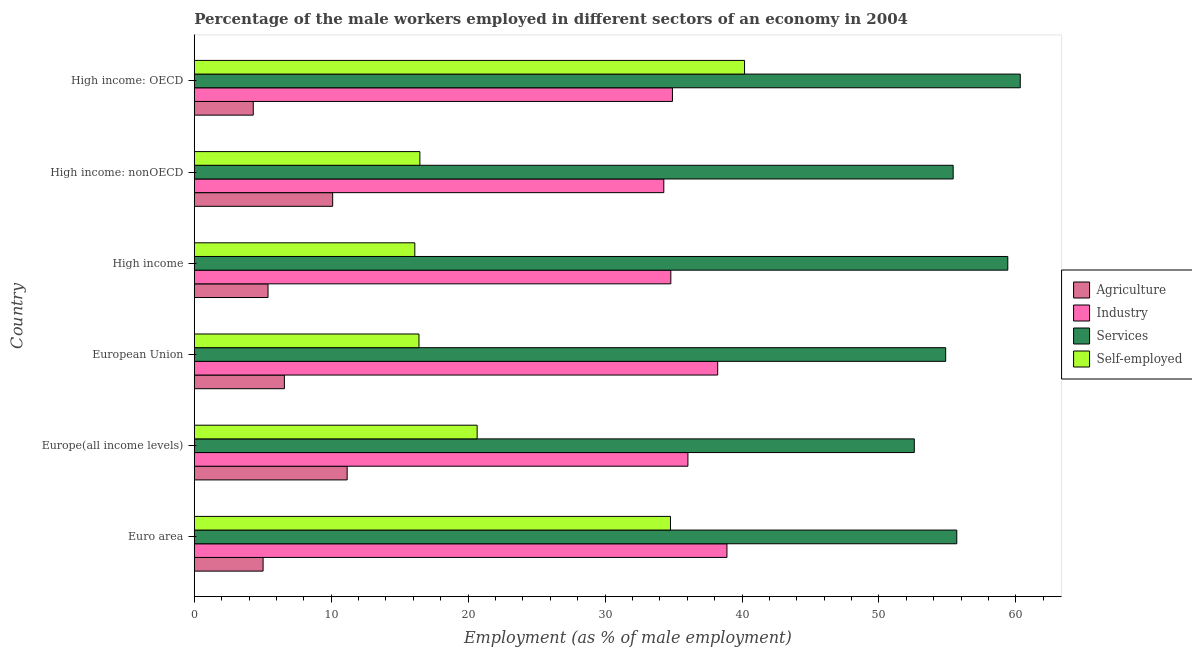Are the number of bars per tick equal to the number of legend labels?
Offer a terse response. Yes. Are the number of bars on each tick of the Y-axis equal?
Offer a very short reply. Yes. What is the label of the 6th group of bars from the top?
Your answer should be very brief. Euro area. In how many cases, is the number of bars for a given country not equal to the number of legend labels?
Provide a succinct answer. 0. What is the percentage of male workers in agriculture in European Union?
Provide a short and direct response. 6.58. Across all countries, what is the maximum percentage of male workers in agriculture?
Provide a short and direct response. 11.16. Across all countries, what is the minimum percentage of male workers in services?
Your answer should be compact. 52.58. In which country was the percentage of self employed male workers maximum?
Keep it short and to the point. High income: OECD. In which country was the percentage of male workers in agriculture minimum?
Make the answer very short. High income: OECD. What is the total percentage of male workers in industry in the graph?
Keep it short and to the point. 217.18. What is the difference between the percentage of male workers in industry in Europe(all income levels) and that in High income?
Provide a succinct answer. 1.25. What is the difference between the percentage of male workers in services in High income and the percentage of male workers in industry in High income: nonOECD?
Your answer should be very brief. 25.12. What is the average percentage of self employed male workers per country?
Give a very brief answer. 24.1. What is the difference between the percentage of male workers in agriculture and percentage of male workers in services in Europe(all income levels)?
Your response must be concise. -41.41. What is the ratio of the percentage of male workers in agriculture in Euro area to that in High income: nonOECD?
Keep it short and to the point. 0.5. Is the difference between the percentage of male workers in services in European Union and High income: OECD greater than the difference between the percentage of male workers in agriculture in European Union and High income: OECD?
Keep it short and to the point. No. What is the difference between the highest and the second highest percentage of male workers in agriculture?
Offer a very short reply. 1.06. What is the difference between the highest and the lowest percentage of male workers in services?
Keep it short and to the point. 7.74. Is the sum of the percentage of male workers in agriculture in Europe(all income levels) and High income: OECD greater than the maximum percentage of self employed male workers across all countries?
Give a very brief answer. No. What does the 1st bar from the top in High income: nonOECD represents?
Your answer should be very brief. Self-employed. What does the 3rd bar from the bottom in High income: OECD represents?
Your answer should be compact. Services. How many bars are there?
Make the answer very short. 24. Are the values on the major ticks of X-axis written in scientific E-notation?
Give a very brief answer. No. Does the graph contain any zero values?
Keep it short and to the point. No. Does the graph contain grids?
Your answer should be very brief. No. How are the legend labels stacked?
Keep it short and to the point. Vertical. What is the title of the graph?
Your answer should be compact. Percentage of the male workers employed in different sectors of an economy in 2004. Does "Finland" appear as one of the legend labels in the graph?
Offer a terse response. No. What is the label or title of the X-axis?
Offer a very short reply. Employment (as % of male employment). What is the Employment (as % of male employment) in Agriculture in Euro area?
Offer a terse response. 5.03. What is the Employment (as % of male employment) in Industry in Euro area?
Ensure brevity in your answer.  38.9. What is the Employment (as % of male employment) of Services in Euro area?
Provide a succinct answer. 55.68. What is the Employment (as % of male employment) in Self-employed in Euro area?
Offer a very short reply. 34.77. What is the Employment (as % of male employment) of Agriculture in Europe(all income levels)?
Your response must be concise. 11.16. What is the Employment (as % of male employment) in Industry in Europe(all income levels)?
Provide a succinct answer. 36.05. What is the Employment (as % of male employment) of Services in Europe(all income levels)?
Make the answer very short. 52.58. What is the Employment (as % of male employment) of Self-employed in Europe(all income levels)?
Ensure brevity in your answer.  20.66. What is the Employment (as % of male employment) of Agriculture in European Union?
Keep it short and to the point. 6.58. What is the Employment (as % of male employment) of Industry in European Union?
Give a very brief answer. 38.22. What is the Employment (as % of male employment) in Services in European Union?
Keep it short and to the point. 54.87. What is the Employment (as % of male employment) of Self-employed in European Union?
Provide a short and direct response. 16.41. What is the Employment (as % of male employment) of Agriculture in High income?
Offer a terse response. 5.39. What is the Employment (as % of male employment) in Industry in High income?
Keep it short and to the point. 34.8. What is the Employment (as % of male employment) in Services in High income?
Offer a terse response. 59.41. What is the Employment (as % of male employment) of Self-employed in High income?
Provide a succinct answer. 16.11. What is the Employment (as % of male employment) in Agriculture in High income: nonOECD?
Provide a succinct answer. 10.11. What is the Employment (as % of male employment) in Industry in High income: nonOECD?
Your answer should be compact. 34.29. What is the Employment (as % of male employment) of Services in High income: nonOECD?
Provide a succinct answer. 55.42. What is the Employment (as % of male employment) of Self-employed in High income: nonOECD?
Your response must be concise. 16.48. What is the Employment (as % of male employment) in Agriculture in High income: OECD?
Keep it short and to the point. 4.31. What is the Employment (as % of male employment) in Industry in High income: OECD?
Your response must be concise. 34.92. What is the Employment (as % of male employment) in Services in High income: OECD?
Keep it short and to the point. 60.32. What is the Employment (as % of male employment) in Self-employed in High income: OECD?
Your answer should be compact. 40.18. Across all countries, what is the maximum Employment (as % of male employment) in Agriculture?
Your response must be concise. 11.16. Across all countries, what is the maximum Employment (as % of male employment) in Industry?
Give a very brief answer. 38.9. Across all countries, what is the maximum Employment (as % of male employment) in Services?
Provide a short and direct response. 60.32. Across all countries, what is the maximum Employment (as % of male employment) in Self-employed?
Keep it short and to the point. 40.18. Across all countries, what is the minimum Employment (as % of male employment) of Agriculture?
Offer a terse response. 4.31. Across all countries, what is the minimum Employment (as % of male employment) of Industry?
Provide a succinct answer. 34.29. Across all countries, what is the minimum Employment (as % of male employment) of Services?
Give a very brief answer. 52.58. Across all countries, what is the minimum Employment (as % of male employment) of Self-employed?
Offer a very short reply. 16.11. What is the total Employment (as % of male employment) in Agriculture in the graph?
Ensure brevity in your answer.  42.57. What is the total Employment (as % of male employment) in Industry in the graph?
Offer a very short reply. 217.18. What is the total Employment (as % of male employment) in Services in the graph?
Give a very brief answer. 338.27. What is the total Employment (as % of male employment) of Self-employed in the graph?
Make the answer very short. 144.6. What is the difference between the Employment (as % of male employment) in Agriculture in Euro area and that in Europe(all income levels)?
Offer a very short reply. -6.14. What is the difference between the Employment (as % of male employment) in Industry in Euro area and that in Europe(all income levels)?
Your response must be concise. 2.85. What is the difference between the Employment (as % of male employment) in Services in Euro area and that in Europe(all income levels)?
Give a very brief answer. 3.1. What is the difference between the Employment (as % of male employment) of Self-employed in Euro area and that in Europe(all income levels)?
Give a very brief answer. 14.12. What is the difference between the Employment (as % of male employment) of Agriculture in Euro area and that in European Union?
Your answer should be very brief. -1.55. What is the difference between the Employment (as % of male employment) in Industry in Euro area and that in European Union?
Your answer should be compact. 0.68. What is the difference between the Employment (as % of male employment) of Services in Euro area and that in European Union?
Provide a succinct answer. 0.81. What is the difference between the Employment (as % of male employment) in Self-employed in Euro area and that in European Union?
Offer a very short reply. 18.37. What is the difference between the Employment (as % of male employment) of Agriculture in Euro area and that in High income?
Your answer should be very brief. -0.36. What is the difference between the Employment (as % of male employment) in Industry in Euro area and that in High income?
Make the answer very short. 4.1. What is the difference between the Employment (as % of male employment) in Services in Euro area and that in High income?
Your response must be concise. -3.73. What is the difference between the Employment (as % of male employment) of Self-employed in Euro area and that in High income?
Your answer should be very brief. 18.67. What is the difference between the Employment (as % of male employment) in Agriculture in Euro area and that in High income: nonOECD?
Provide a succinct answer. -5.08. What is the difference between the Employment (as % of male employment) of Industry in Euro area and that in High income: nonOECD?
Keep it short and to the point. 4.61. What is the difference between the Employment (as % of male employment) of Services in Euro area and that in High income: nonOECD?
Offer a terse response. 0.26. What is the difference between the Employment (as % of male employment) in Self-employed in Euro area and that in High income: nonOECD?
Offer a terse response. 18.3. What is the difference between the Employment (as % of male employment) in Agriculture in Euro area and that in High income: OECD?
Your response must be concise. 0.72. What is the difference between the Employment (as % of male employment) in Industry in Euro area and that in High income: OECD?
Make the answer very short. 3.98. What is the difference between the Employment (as % of male employment) of Services in Euro area and that in High income: OECD?
Keep it short and to the point. -4.64. What is the difference between the Employment (as % of male employment) of Self-employed in Euro area and that in High income: OECD?
Make the answer very short. -5.41. What is the difference between the Employment (as % of male employment) in Agriculture in Europe(all income levels) and that in European Union?
Make the answer very short. 4.58. What is the difference between the Employment (as % of male employment) in Industry in Europe(all income levels) and that in European Union?
Keep it short and to the point. -2.17. What is the difference between the Employment (as % of male employment) in Services in Europe(all income levels) and that in European Union?
Provide a short and direct response. -2.29. What is the difference between the Employment (as % of male employment) in Self-employed in Europe(all income levels) and that in European Union?
Make the answer very short. 4.25. What is the difference between the Employment (as % of male employment) in Agriculture in Europe(all income levels) and that in High income?
Keep it short and to the point. 5.78. What is the difference between the Employment (as % of male employment) in Industry in Europe(all income levels) and that in High income?
Provide a short and direct response. 1.25. What is the difference between the Employment (as % of male employment) of Services in Europe(all income levels) and that in High income?
Offer a very short reply. -6.83. What is the difference between the Employment (as % of male employment) of Self-employed in Europe(all income levels) and that in High income?
Your answer should be very brief. 4.55. What is the difference between the Employment (as % of male employment) in Agriculture in Europe(all income levels) and that in High income: nonOECD?
Provide a short and direct response. 1.06. What is the difference between the Employment (as % of male employment) of Industry in Europe(all income levels) and that in High income: nonOECD?
Make the answer very short. 1.76. What is the difference between the Employment (as % of male employment) of Services in Europe(all income levels) and that in High income: nonOECD?
Keep it short and to the point. -2.84. What is the difference between the Employment (as % of male employment) of Self-employed in Europe(all income levels) and that in High income: nonOECD?
Make the answer very short. 4.18. What is the difference between the Employment (as % of male employment) of Agriculture in Europe(all income levels) and that in High income: OECD?
Keep it short and to the point. 6.86. What is the difference between the Employment (as % of male employment) in Industry in Europe(all income levels) and that in High income: OECD?
Provide a short and direct response. 1.13. What is the difference between the Employment (as % of male employment) of Services in Europe(all income levels) and that in High income: OECD?
Provide a succinct answer. -7.74. What is the difference between the Employment (as % of male employment) of Self-employed in Europe(all income levels) and that in High income: OECD?
Offer a terse response. -19.53. What is the difference between the Employment (as % of male employment) in Agriculture in European Union and that in High income?
Make the answer very short. 1.19. What is the difference between the Employment (as % of male employment) in Industry in European Union and that in High income?
Keep it short and to the point. 3.42. What is the difference between the Employment (as % of male employment) of Services in European Union and that in High income?
Offer a terse response. -4.54. What is the difference between the Employment (as % of male employment) of Self-employed in European Union and that in High income?
Offer a terse response. 0.3. What is the difference between the Employment (as % of male employment) of Agriculture in European Union and that in High income: nonOECD?
Provide a short and direct response. -3.53. What is the difference between the Employment (as % of male employment) of Industry in European Union and that in High income: nonOECD?
Your answer should be compact. 3.94. What is the difference between the Employment (as % of male employment) of Services in European Union and that in High income: nonOECD?
Your response must be concise. -0.55. What is the difference between the Employment (as % of male employment) in Self-employed in European Union and that in High income: nonOECD?
Your answer should be compact. -0.07. What is the difference between the Employment (as % of male employment) in Agriculture in European Union and that in High income: OECD?
Give a very brief answer. 2.27. What is the difference between the Employment (as % of male employment) in Industry in European Union and that in High income: OECD?
Your answer should be compact. 3.31. What is the difference between the Employment (as % of male employment) of Services in European Union and that in High income: OECD?
Your response must be concise. -5.45. What is the difference between the Employment (as % of male employment) of Self-employed in European Union and that in High income: OECD?
Your answer should be compact. -23.78. What is the difference between the Employment (as % of male employment) in Agriculture in High income and that in High income: nonOECD?
Offer a very short reply. -4.72. What is the difference between the Employment (as % of male employment) in Industry in High income and that in High income: nonOECD?
Provide a short and direct response. 0.51. What is the difference between the Employment (as % of male employment) in Services in High income and that in High income: nonOECD?
Keep it short and to the point. 3.99. What is the difference between the Employment (as % of male employment) in Self-employed in High income and that in High income: nonOECD?
Offer a terse response. -0.37. What is the difference between the Employment (as % of male employment) of Agriculture in High income and that in High income: OECD?
Offer a very short reply. 1.08. What is the difference between the Employment (as % of male employment) of Industry in High income and that in High income: OECD?
Your answer should be very brief. -0.12. What is the difference between the Employment (as % of male employment) of Services in High income and that in High income: OECD?
Keep it short and to the point. -0.91. What is the difference between the Employment (as % of male employment) of Self-employed in High income and that in High income: OECD?
Keep it short and to the point. -24.08. What is the difference between the Employment (as % of male employment) in Agriculture in High income: nonOECD and that in High income: OECD?
Offer a terse response. 5.8. What is the difference between the Employment (as % of male employment) in Industry in High income: nonOECD and that in High income: OECD?
Your response must be concise. -0.63. What is the difference between the Employment (as % of male employment) of Services in High income: nonOECD and that in High income: OECD?
Offer a terse response. -4.9. What is the difference between the Employment (as % of male employment) of Self-employed in High income: nonOECD and that in High income: OECD?
Your response must be concise. -23.71. What is the difference between the Employment (as % of male employment) in Agriculture in Euro area and the Employment (as % of male employment) in Industry in Europe(all income levels)?
Your response must be concise. -31.02. What is the difference between the Employment (as % of male employment) in Agriculture in Euro area and the Employment (as % of male employment) in Services in Europe(all income levels)?
Your response must be concise. -47.55. What is the difference between the Employment (as % of male employment) in Agriculture in Euro area and the Employment (as % of male employment) in Self-employed in Europe(all income levels)?
Make the answer very short. -15.63. What is the difference between the Employment (as % of male employment) of Industry in Euro area and the Employment (as % of male employment) of Services in Europe(all income levels)?
Your answer should be very brief. -13.68. What is the difference between the Employment (as % of male employment) of Industry in Euro area and the Employment (as % of male employment) of Self-employed in Europe(all income levels)?
Your answer should be compact. 18.24. What is the difference between the Employment (as % of male employment) in Services in Euro area and the Employment (as % of male employment) in Self-employed in Europe(all income levels)?
Ensure brevity in your answer.  35.03. What is the difference between the Employment (as % of male employment) of Agriculture in Euro area and the Employment (as % of male employment) of Industry in European Union?
Keep it short and to the point. -33.2. What is the difference between the Employment (as % of male employment) in Agriculture in Euro area and the Employment (as % of male employment) in Services in European Union?
Make the answer very short. -49.84. What is the difference between the Employment (as % of male employment) in Agriculture in Euro area and the Employment (as % of male employment) in Self-employed in European Union?
Provide a short and direct response. -11.38. What is the difference between the Employment (as % of male employment) in Industry in Euro area and the Employment (as % of male employment) in Services in European Union?
Your response must be concise. -15.97. What is the difference between the Employment (as % of male employment) in Industry in Euro area and the Employment (as % of male employment) in Self-employed in European Union?
Make the answer very short. 22.49. What is the difference between the Employment (as % of male employment) of Services in Euro area and the Employment (as % of male employment) of Self-employed in European Union?
Provide a short and direct response. 39.27. What is the difference between the Employment (as % of male employment) of Agriculture in Euro area and the Employment (as % of male employment) of Industry in High income?
Offer a terse response. -29.77. What is the difference between the Employment (as % of male employment) in Agriculture in Euro area and the Employment (as % of male employment) in Services in High income?
Make the answer very short. -54.38. What is the difference between the Employment (as % of male employment) of Agriculture in Euro area and the Employment (as % of male employment) of Self-employed in High income?
Offer a very short reply. -11.08. What is the difference between the Employment (as % of male employment) of Industry in Euro area and the Employment (as % of male employment) of Services in High income?
Provide a short and direct response. -20.51. What is the difference between the Employment (as % of male employment) in Industry in Euro area and the Employment (as % of male employment) in Self-employed in High income?
Make the answer very short. 22.79. What is the difference between the Employment (as % of male employment) of Services in Euro area and the Employment (as % of male employment) of Self-employed in High income?
Your answer should be compact. 39.58. What is the difference between the Employment (as % of male employment) of Agriculture in Euro area and the Employment (as % of male employment) of Industry in High income: nonOECD?
Your answer should be very brief. -29.26. What is the difference between the Employment (as % of male employment) of Agriculture in Euro area and the Employment (as % of male employment) of Services in High income: nonOECD?
Your response must be concise. -50.39. What is the difference between the Employment (as % of male employment) in Agriculture in Euro area and the Employment (as % of male employment) in Self-employed in High income: nonOECD?
Ensure brevity in your answer.  -11.45. What is the difference between the Employment (as % of male employment) of Industry in Euro area and the Employment (as % of male employment) of Services in High income: nonOECD?
Offer a very short reply. -16.52. What is the difference between the Employment (as % of male employment) of Industry in Euro area and the Employment (as % of male employment) of Self-employed in High income: nonOECD?
Provide a short and direct response. 22.42. What is the difference between the Employment (as % of male employment) of Services in Euro area and the Employment (as % of male employment) of Self-employed in High income: nonOECD?
Your answer should be compact. 39.21. What is the difference between the Employment (as % of male employment) in Agriculture in Euro area and the Employment (as % of male employment) in Industry in High income: OECD?
Give a very brief answer. -29.89. What is the difference between the Employment (as % of male employment) of Agriculture in Euro area and the Employment (as % of male employment) of Services in High income: OECD?
Make the answer very short. -55.29. What is the difference between the Employment (as % of male employment) of Agriculture in Euro area and the Employment (as % of male employment) of Self-employed in High income: OECD?
Your answer should be very brief. -35.16. What is the difference between the Employment (as % of male employment) of Industry in Euro area and the Employment (as % of male employment) of Services in High income: OECD?
Your answer should be very brief. -21.42. What is the difference between the Employment (as % of male employment) of Industry in Euro area and the Employment (as % of male employment) of Self-employed in High income: OECD?
Your response must be concise. -1.28. What is the difference between the Employment (as % of male employment) of Services in Euro area and the Employment (as % of male employment) of Self-employed in High income: OECD?
Give a very brief answer. 15.5. What is the difference between the Employment (as % of male employment) of Agriculture in Europe(all income levels) and the Employment (as % of male employment) of Industry in European Union?
Offer a very short reply. -27.06. What is the difference between the Employment (as % of male employment) in Agriculture in Europe(all income levels) and the Employment (as % of male employment) in Services in European Union?
Provide a short and direct response. -43.71. What is the difference between the Employment (as % of male employment) of Agriculture in Europe(all income levels) and the Employment (as % of male employment) of Self-employed in European Union?
Give a very brief answer. -5.24. What is the difference between the Employment (as % of male employment) of Industry in Europe(all income levels) and the Employment (as % of male employment) of Services in European Union?
Your response must be concise. -18.82. What is the difference between the Employment (as % of male employment) in Industry in Europe(all income levels) and the Employment (as % of male employment) in Self-employed in European Union?
Provide a succinct answer. 19.64. What is the difference between the Employment (as % of male employment) of Services in Europe(all income levels) and the Employment (as % of male employment) of Self-employed in European Union?
Your response must be concise. 36.17. What is the difference between the Employment (as % of male employment) in Agriculture in Europe(all income levels) and the Employment (as % of male employment) in Industry in High income?
Provide a succinct answer. -23.64. What is the difference between the Employment (as % of male employment) in Agriculture in Europe(all income levels) and the Employment (as % of male employment) in Services in High income?
Offer a terse response. -48.24. What is the difference between the Employment (as % of male employment) in Agriculture in Europe(all income levels) and the Employment (as % of male employment) in Self-employed in High income?
Provide a short and direct response. -4.94. What is the difference between the Employment (as % of male employment) of Industry in Europe(all income levels) and the Employment (as % of male employment) of Services in High income?
Ensure brevity in your answer.  -23.36. What is the difference between the Employment (as % of male employment) in Industry in Europe(all income levels) and the Employment (as % of male employment) in Self-employed in High income?
Your answer should be compact. 19.94. What is the difference between the Employment (as % of male employment) in Services in Europe(all income levels) and the Employment (as % of male employment) in Self-employed in High income?
Your answer should be compact. 36.47. What is the difference between the Employment (as % of male employment) in Agriculture in Europe(all income levels) and the Employment (as % of male employment) in Industry in High income: nonOECD?
Your answer should be very brief. -23.12. What is the difference between the Employment (as % of male employment) of Agriculture in Europe(all income levels) and the Employment (as % of male employment) of Services in High income: nonOECD?
Offer a very short reply. -44.25. What is the difference between the Employment (as % of male employment) in Agriculture in Europe(all income levels) and the Employment (as % of male employment) in Self-employed in High income: nonOECD?
Keep it short and to the point. -5.31. What is the difference between the Employment (as % of male employment) in Industry in Europe(all income levels) and the Employment (as % of male employment) in Services in High income: nonOECD?
Give a very brief answer. -19.37. What is the difference between the Employment (as % of male employment) in Industry in Europe(all income levels) and the Employment (as % of male employment) in Self-employed in High income: nonOECD?
Your answer should be very brief. 19.57. What is the difference between the Employment (as % of male employment) of Services in Europe(all income levels) and the Employment (as % of male employment) of Self-employed in High income: nonOECD?
Ensure brevity in your answer.  36.1. What is the difference between the Employment (as % of male employment) of Agriculture in Europe(all income levels) and the Employment (as % of male employment) of Industry in High income: OECD?
Provide a short and direct response. -23.75. What is the difference between the Employment (as % of male employment) in Agriculture in Europe(all income levels) and the Employment (as % of male employment) in Services in High income: OECD?
Provide a short and direct response. -49.15. What is the difference between the Employment (as % of male employment) of Agriculture in Europe(all income levels) and the Employment (as % of male employment) of Self-employed in High income: OECD?
Offer a terse response. -29.02. What is the difference between the Employment (as % of male employment) of Industry in Europe(all income levels) and the Employment (as % of male employment) of Services in High income: OECD?
Your response must be concise. -24.27. What is the difference between the Employment (as % of male employment) in Industry in Europe(all income levels) and the Employment (as % of male employment) in Self-employed in High income: OECD?
Your answer should be compact. -4.14. What is the difference between the Employment (as % of male employment) of Services in Europe(all income levels) and the Employment (as % of male employment) of Self-employed in High income: OECD?
Make the answer very short. 12.4. What is the difference between the Employment (as % of male employment) of Agriculture in European Union and the Employment (as % of male employment) of Industry in High income?
Your response must be concise. -28.22. What is the difference between the Employment (as % of male employment) in Agriculture in European Union and the Employment (as % of male employment) in Services in High income?
Offer a very short reply. -52.83. What is the difference between the Employment (as % of male employment) in Agriculture in European Union and the Employment (as % of male employment) in Self-employed in High income?
Provide a short and direct response. -9.52. What is the difference between the Employment (as % of male employment) in Industry in European Union and the Employment (as % of male employment) in Services in High income?
Offer a terse response. -21.18. What is the difference between the Employment (as % of male employment) in Industry in European Union and the Employment (as % of male employment) in Self-employed in High income?
Keep it short and to the point. 22.12. What is the difference between the Employment (as % of male employment) of Services in European Union and the Employment (as % of male employment) of Self-employed in High income?
Offer a terse response. 38.76. What is the difference between the Employment (as % of male employment) of Agriculture in European Union and the Employment (as % of male employment) of Industry in High income: nonOECD?
Your response must be concise. -27.71. What is the difference between the Employment (as % of male employment) in Agriculture in European Union and the Employment (as % of male employment) in Services in High income: nonOECD?
Offer a very short reply. -48.84. What is the difference between the Employment (as % of male employment) in Agriculture in European Union and the Employment (as % of male employment) in Self-employed in High income: nonOECD?
Provide a short and direct response. -9.89. What is the difference between the Employment (as % of male employment) in Industry in European Union and the Employment (as % of male employment) in Services in High income: nonOECD?
Keep it short and to the point. -17.2. What is the difference between the Employment (as % of male employment) in Industry in European Union and the Employment (as % of male employment) in Self-employed in High income: nonOECD?
Provide a short and direct response. 21.75. What is the difference between the Employment (as % of male employment) in Services in European Union and the Employment (as % of male employment) in Self-employed in High income: nonOECD?
Ensure brevity in your answer.  38.39. What is the difference between the Employment (as % of male employment) of Agriculture in European Union and the Employment (as % of male employment) of Industry in High income: OECD?
Provide a succinct answer. -28.34. What is the difference between the Employment (as % of male employment) of Agriculture in European Union and the Employment (as % of male employment) of Services in High income: OECD?
Your answer should be compact. -53.74. What is the difference between the Employment (as % of male employment) in Agriculture in European Union and the Employment (as % of male employment) in Self-employed in High income: OECD?
Your answer should be compact. -33.6. What is the difference between the Employment (as % of male employment) in Industry in European Union and the Employment (as % of male employment) in Services in High income: OECD?
Offer a terse response. -22.09. What is the difference between the Employment (as % of male employment) of Industry in European Union and the Employment (as % of male employment) of Self-employed in High income: OECD?
Your answer should be compact. -1.96. What is the difference between the Employment (as % of male employment) in Services in European Union and the Employment (as % of male employment) in Self-employed in High income: OECD?
Provide a succinct answer. 14.69. What is the difference between the Employment (as % of male employment) in Agriculture in High income and the Employment (as % of male employment) in Industry in High income: nonOECD?
Your answer should be very brief. -28.9. What is the difference between the Employment (as % of male employment) of Agriculture in High income and the Employment (as % of male employment) of Services in High income: nonOECD?
Give a very brief answer. -50.03. What is the difference between the Employment (as % of male employment) of Agriculture in High income and the Employment (as % of male employment) of Self-employed in High income: nonOECD?
Your response must be concise. -11.09. What is the difference between the Employment (as % of male employment) of Industry in High income and the Employment (as % of male employment) of Services in High income: nonOECD?
Your answer should be compact. -20.62. What is the difference between the Employment (as % of male employment) in Industry in High income and the Employment (as % of male employment) in Self-employed in High income: nonOECD?
Keep it short and to the point. 18.33. What is the difference between the Employment (as % of male employment) in Services in High income and the Employment (as % of male employment) in Self-employed in High income: nonOECD?
Offer a very short reply. 42.93. What is the difference between the Employment (as % of male employment) in Agriculture in High income and the Employment (as % of male employment) in Industry in High income: OECD?
Offer a very short reply. -29.53. What is the difference between the Employment (as % of male employment) in Agriculture in High income and the Employment (as % of male employment) in Services in High income: OECD?
Provide a succinct answer. -54.93. What is the difference between the Employment (as % of male employment) of Agriculture in High income and the Employment (as % of male employment) of Self-employed in High income: OECD?
Provide a succinct answer. -34.8. What is the difference between the Employment (as % of male employment) in Industry in High income and the Employment (as % of male employment) in Services in High income: OECD?
Your answer should be compact. -25.52. What is the difference between the Employment (as % of male employment) in Industry in High income and the Employment (as % of male employment) in Self-employed in High income: OECD?
Your answer should be very brief. -5.38. What is the difference between the Employment (as % of male employment) of Services in High income and the Employment (as % of male employment) of Self-employed in High income: OECD?
Ensure brevity in your answer.  19.22. What is the difference between the Employment (as % of male employment) in Agriculture in High income: nonOECD and the Employment (as % of male employment) in Industry in High income: OECD?
Keep it short and to the point. -24.81. What is the difference between the Employment (as % of male employment) in Agriculture in High income: nonOECD and the Employment (as % of male employment) in Services in High income: OECD?
Give a very brief answer. -50.21. What is the difference between the Employment (as % of male employment) of Agriculture in High income: nonOECD and the Employment (as % of male employment) of Self-employed in High income: OECD?
Your response must be concise. -30.08. What is the difference between the Employment (as % of male employment) in Industry in High income: nonOECD and the Employment (as % of male employment) in Services in High income: OECD?
Keep it short and to the point. -26.03. What is the difference between the Employment (as % of male employment) of Industry in High income: nonOECD and the Employment (as % of male employment) of Self-employed in High income: OECD?
Provide a succinct answer. -5.9. What is the difference between the Employment (as % of male employment) of Services in High income: nonOECD and the Employment (as % of male employment) of Self-employed in High income: OECD?
Your answer should be very brief. 15.23. What is the average Employment (as % of male employment) of Agriculture per country?
Your answer should be very brief. 7.1. What is the average Employment (as % of male employment) of Industry per country?
Keep it short and to the point. 36.2. What is the average Employment (as % of male employment) of Services per country?
Make the answer very short. 56.38. What is the average Employment (as % of male employment) of Self-employed per country?
Offer a terse response. 24.1. What is the difference between the Employment (as % of male employment) of Agriculture and Employment (as % of male employment) of Industry in Euro area?
Your response must be concise. -33.87. What is the difference between the Employment (as % of male employment) of Agriculture and Employment (as % of male employment) of Services in Euro area?
Ensure brevity in your answer.  -50.66. What is the difference between the Employment (as % of male employment) in Agriculture and Employment (as % of male employment) in Self-employed in Euro area?
Keep it short and to the point. -29.75. What is the difference between the Employment (as % of male employment) of Industry and Employment (as % of male employment) of Services in Euro area?
Offer a terse response. -16.78. What is the difference between the Employment (as % of male employment) of Industry and Employment (as % of male employment) of Self-employed in Euro area?
Offer a terse response. 4.12. What is the difference between the Employment (as % of male employment) of Services and Employment (as % of male employment) of Self-employed in Euro area?
Your answer should be very brief. 20.91. What is the difference between the Employment (as % of male employment) of Agriculture and Employment (as % of male employment) of Industry in Europe(all income levels)?
Your response must be concise. -24.88. What is the difference between the Employment (as % of male employment) of Agriculture and Employment (as % of male employment) of Services in Europe(all income levels)?
Provide a succinct answer. -41.42. What is the difference between the Employment (as % of male employment) in Agriculture and Employment (as % of male employment) in Self-employed in Europe(all income levels)?
Offer a very short reply. -9.49. What is the difference between the Employment (as % of male employment) in Industry and Employment (as % of male employment) in Services in Europe(all income levels)?
Give a very brief answer. -16.53. What is the difference between the Employment (as % of male employment) in Industry and Employment (as % of male employment) in Self-employed in Europe(all income levels)?
Ensure brevity in your answer.  15.39. What is the difference between the Employment (as % of male employment) of Services and Employment (as % of male employment) of Self-employed in Europe(all income levels)?
Give a very brief answer. 31.92. What is the difference between the Employment (as % of male employment) in Agriculture and Employment (as % of male employment) in Industry in European Union?
Your response must be concise. -31.64. What is the difference between the Employment (as % of male employment) of Agriculture and Employment (as % of male employment) of Services in European Union?
Your answer should be compact. -48.29. What is the difference between the Employment (as % of male employment) of Agriculture and Employment (as % of male employment) of Self-employed in European Union?
Your answer should be compact. -9.83. What is the difference between the Employment (as % of male employment) in Industry and Employment (as % of male employment) in Services in European Union?
Ensure brevity in your answer.  -16.65. What is the difference between the Employment (as % of male employment) in Industry and Employment (as % of male employment) in Self-employed in European Union?
Your answer should be compact. 21.81. What is the difference between the Employment (as % of male employment) in Services and Employment (as % of male employment) in Self-employed in European Union?
Ensure brevity in your answer.  38.46. What is the difference between the Employment (as % of male employment) in Agriculture and Employment (as % of male employment) in Industry in High income?
Give a very brief answer. -29.41. What is the difference between the Employment (as % of male employment) in Agriculture and Employment (as % of male employment) in Services in High income?
Give a very brief answer. -54.02. What is the difference between the Employment (as % of male employment) in Agriculture and Employment (as % of male employment) in Self-employed in High income?
Provide a succinct answer. -10.72. What is the difference between the Employment (as % of male employment) in Industry and Employment (as % of male employment) in Services in High income?
Offer a very short reply. -24.61. What is the difference between the Employment (as % of male employment) of Industry and Employment (as % of male employment) of Self-employed in High income?
Offer a very short reply. 18.69. What is the difference between the Employment (as % of male employment) in Services and Employment (as % of male employment) in Self-employed in High income?
Provide a short and direct response. 43.3. What is the difference between the Employment (as % of male employment) in Agriculture and Employment (as % of male employment) in Industry in High income: nonOECD?
Your answer should be compact. -24.18. What is the difference between the Employment (as % of male employment) in Agriculture and Employment (as % of male employment) in Services in High income: nonOECD?
Your response must be concise. -45.31. What is the difference between the Employment (as % of male employment) in Agriculture and Employment (as % of male employment) in Self-employed in High income: nonOECD?
Offer a very short reply. -6.37. What is the difference between the Employment (as % of male employment) in Industry and Employment (as % of male employment) in Services in High income: nonOECD?
Keep it short and to the point. -21.13. What is the difference between the Employment (as % of male employment) in Industry and Employment (as % of male employment) in Self-employed in High income: nonOECD?
Your response must be concise. 17.81. What is the difference between the Employment (as % of male employment) of Services and Employment (as % of male employment) of Self-employed in High income: nonOECD?
Ensure brevity in your answer.  38.94. What is the difference between the Employment (as % of male employment) in Agriculture and Employment (as % of male employment) in Industry in High income: OECD?
Your answer should be very brief. -30.61. What is the difference between the Employment (as % of male employment) of Agriculture and Employment (as % of male employment) of Services in High income: OECD?
Your response must be concise. -56.01. What is the difference between the Employment (as % of male employment) of Agriculture and Employment (as % of male employment) of Self-employed in High income: OECD?
Keep it short and to the point. -35.87. What is the difference between the Employment (as % of male employment) in Industry and Employment (as % of male employment) in Services in High income: OECD?
Your answer should be compact. -25.4. What is the difference between the Employment (as % of male employment) of Industry and Employment (as % of male employment) of Self-employed in High income: OECD?
Your answer should be compact. -5.27. What is the difference between the Employment (as % of male employment) in Services and Employment (as % of male employment) in Self-employed in High income: OECD?
Give a very brief answer. 20.13. What is the ratio of the Employment (as % of male employment) of Agriculture in Euro area to that in Europe(all income levels)?
Provide a succinct answer. 0.45. What is the ratio of the Employment (as % of male employment) of Industry in Euro area to that in Europe(all income levels)?
Your response must be concise. 1.08. What is the ratio of the Employment (as % of male employment) in Services in Euro area to that in Europe(all income levels)?
Make the answer very short. 1.06. What is the ratio of the Employment (as % of male employment) in Self-employed in Euro area to that in Europe(all income levels)?
Make the answer very short. 1.68. What is the ratio of the Employment (as % of male employment) in Agriculture in Euro area to that in European Union?
Give a very brief answer. 0.76. What is the ratio of the Employment (as % of male employment) of Industry in Euro area to that in European Union?
Offer a very short reply. 1.02. What is the ratio of the Employment (as % of male employment) of Services in Euro area to that in European Union?
Your answer should be very brief. 1.01. What is the ratio of the Employment (as % of male employment) of Self-employed in Euro area to that in European Union?
Your response must be concise. 2.12. What is the ratio of the Employment (as % of male employment) in Agriculture in Euro area to that in High income?
Your answer should be very brief. 0.93. What is the ratio of the Employment (as % of male employment) in Industry in Euro area to that in High income?
Make the answer very short. 1.12. What is the ratio of the Employment (as % of male employment) in Services in Euro area to that in High income?
Your response must be concise. 0.94. What is the ratio of the Employment (as % of male employment) of Self-employed in Euro area to that in High income?
Your answer should be very brief. 2.16. What is the ratio of the Employment (as % of male employment) of Agriculture in Euro area to that in High income: nonOECD?
Provide a succinct answer. 0.5. What is the ratio of the Employment (as % of male employment) of Industry in Euro area to that in High income: nonOECD?
Your answer should be very brief. 1.13. What is the ratio of the Employment (as % of male employment) of Services in Euro area to that in High income: nonOECD?
Provide a short and direct response. 1. What is the ratio of the Employment (as % of male employment) of Self-employed in Euro area to that in High income: nonOECD?
Your answer should be very brief. 2.11. What is the ratio of the Employment (as % of male employment) of Agriculture in Euro area to that in High income: OECD?
Keep it short and to the point. 1.17. What is the ratio of the Employment (as % of male employment) of Industry in Euro area to that in High income: OECD?
Provide a short and direct response. 1.11. What is the ratio of the Employment (as % of male employment) of Services in Euro area to that in High income: OECD?
Make the answer very short. 0.92. What is the ratio of the Employment (as % of male employment) in Self-employed in Euro area to that in High income: OECD?
Your answer should be compact. 0.87. What is the ratio of the Employment (as % of male employment) in Agriculture in Europe(all income levels) to that in European Union?
Your answer should be compact. 1.7. What is the ratio of the Employment (as % of male employment) in Industry in Europe(all income levels) to that in European Union?
Provide a short and direct response. 0.94. What is the ratio of the Employment (as % of male employment) in Self-employed in Europe(all income levels) to that in European Union?
Provide a short and direct response. 1.26. What is the ratio of the Employment (as % of male employment) of Agriculture in Europe(all income levels) to that in High income?
Provide a short and direct response. 2.07. What is the ratio of the Employment (as % of male employment) in Industry in Europe(all income levels) to that in High income?
Your response must be concise. 1.04. What is the ratio of the Employment (as % of male employment) in Services in Europe(all income levels) to that in High income?
Keep it short and to the point. 0.89. What is the ratio of the Employment (as % of male employment) in Self-employed in Europe(all income levels) to that in High income?
Keep it short and to the point. 1.28. What is the ratio of the Employment (as % of male employment) in Agriculture in Europe(all income levels) to that in High income: nonOECD?
Provide a short and direct response. 1.1. What is the ratio of the Employment (as % of male employment) of Industry in Europe(all income levels) to that in High income: nonOECD?
Your response must be concise. 1.05. What is the ratio of the Employment (as % of male employment) of Services in Europe(all income levels) to that in High income: nonOECD?
Offer a terse response. 0.95. What is the ratio of the Employment (as % of male employment) of Self-employed in Europe(all income levels) to that in High income: nonOECD?
Offer a terse response. 1.25. What is the ratio of the Employment (as % of male employment) of Agriculture in Europe(all income levels) to that in High income: OECD?
Your response must be concise. 2.59. What is the ratio of the Employment (as % of male employment) in Industry in Europe(all income levels) to that in High income: OECD?
Your response must be concise. 1.03. What is the ratio of the Employment (as % of male employment) in Services in Europe(all income levels) to that in High income: OECD?
Your response must be concise. 0.87. What is the ratio of the Employment (as % of male employment) of Self-employed in Europe(all income levels) to that in High income: OECD?
Keep it short and to the point. 0.51. What is the ratio of the Employment (as % of male employment) in Agriculture in European Union to that in High income?
Keep it short and to the point. 1.22. What is the ratio of the Employment (as % of male employment) in Industry in European Union to that in High income?
Your response must be concise. 1.1. What is the ratio of the Employment (as % of male employment) in Services in European Union to that in High income?
Offer a very short reply. 0.92. What is the ratio of the Employment (as % of male employment) in Self-employed in European Union to that in High income?
Provide a succinct answer. 1.02. What is the ratio of the Employment (as % of male employment) of Agriculture in European Union to that in High income: nonOECD?
Your response must be concise. 0.65. What is the ratio of the Employment (as % of male employment) of Industry in European Union to that in High income: nonOECD?
Offer a terse response. 1.11. What is the ratio of the Employment (as % of male employment) of Services in European Union to that in High income: nonOECD?
Your answer should be compact. 0.99. What is the ratio of the Employment (as % of male employment) of Agriculture in European Union to that in High income: OECD?
Your response must be concise. 1.53. What is the ratio of the Employment (as % of male employment) of Industry in European Union to that in High income: OECD?
Keep it short and to the point. 1.09. What is the ratio of the Employment (as % of male employment) of Services in European Union to that in High income: OECD?
Offer a very short reply. 0.91. What is the ratio of the Employment (as % of male employment) of Self-employed in European Union to that in High income: OECD?
Make the answer very short. 0.41. What is the ratio of the Employment (as % of male employment) of Agriculture in High income to that in High income: nonOECD?
Offer a very short reply. 0.53. What is the ratio of the Employment (as % of male employment) of Industry in High income to that in High income: nonOECD?
Ensure brevity in your answer.  1.01. What is the ratio of the Employment (as % of male employment) of Services in High income to that in High income: nonOECD?
Your answer should be compact. 1.07. What is the ratio of the Employment (as % of male employment) in Self-employed in High income to that in High income: nonOECD?
Make the answer very short. 0.98. What is the ratio of the Employment (as % of male employment) in Agriculture in High income to that in High income: OECD?
Offer a terse response. 1.25. What is the ratio of the Employment (as % of male employment) of Industry in High income to that in High income: OECD?
Offer a terse response. 1. What is the ratio of the Employment (as % of male employment) in Services in High income to that in High income: OECD?
Give a very brief answer. 0.98. What is the ratio of the Employment (as % of male employment) in Self-employed in High income to that in High income: OECD?
Your answer should be very brief. 0.4. What is the ratio of the Employment (as % of male employment) in Agriculture in High income: nonOECD to that in High income: OECD?
Your response must be concise. 2.35. What is the ratio of the Employment (as % of male employment) of Industry in High income: nonOECD to that in High income: OECD?
Your response must be concise. 0.98. What is the ratio of the Employment (as % of male employment) in Services in High income: nonOECD to that in High income: OECD?
Your response must be concise. 0.92. What is the ratio of the Employment (as % of male employment) of Self-employed in High income: nonOECD to that in High income: OECD?
Provide a short and direct response. 0.41. What is the difference between the highest and the second highest Employment (as % of male employment) in Agriculture?
Your response must be concise. 1.06. What is the difference between the highest and the second highest Employment (as % of male employment) in Industry?
Your answer should be very brief. 0.68. What is the difference between the highest and the second highest Employment (as % of male employment) in Services?
Ensure brevity in your answer.  0.91. What is the difference between the highest and the second highest Employment (as % of male employment) in Self-employed?
Offer a very short reply. 5.41. What is the difference between the highest and the lowest Employment (as % of male employment) in Agriculture?
Your answer should be compact. 6.86. What is the difference between the highest and the lowest Employment (as % of male employment) in Industry?
Your answer should be very brief. 4.61. What is the difference between the highest and the lowest Employment (as % of male employment) of Services?
Offer a very short reply. 7.74. What is the difference between the highest and the lowest Employment (as % of male employment) in Self-employed?
Offer a very short reply. 24.08. 